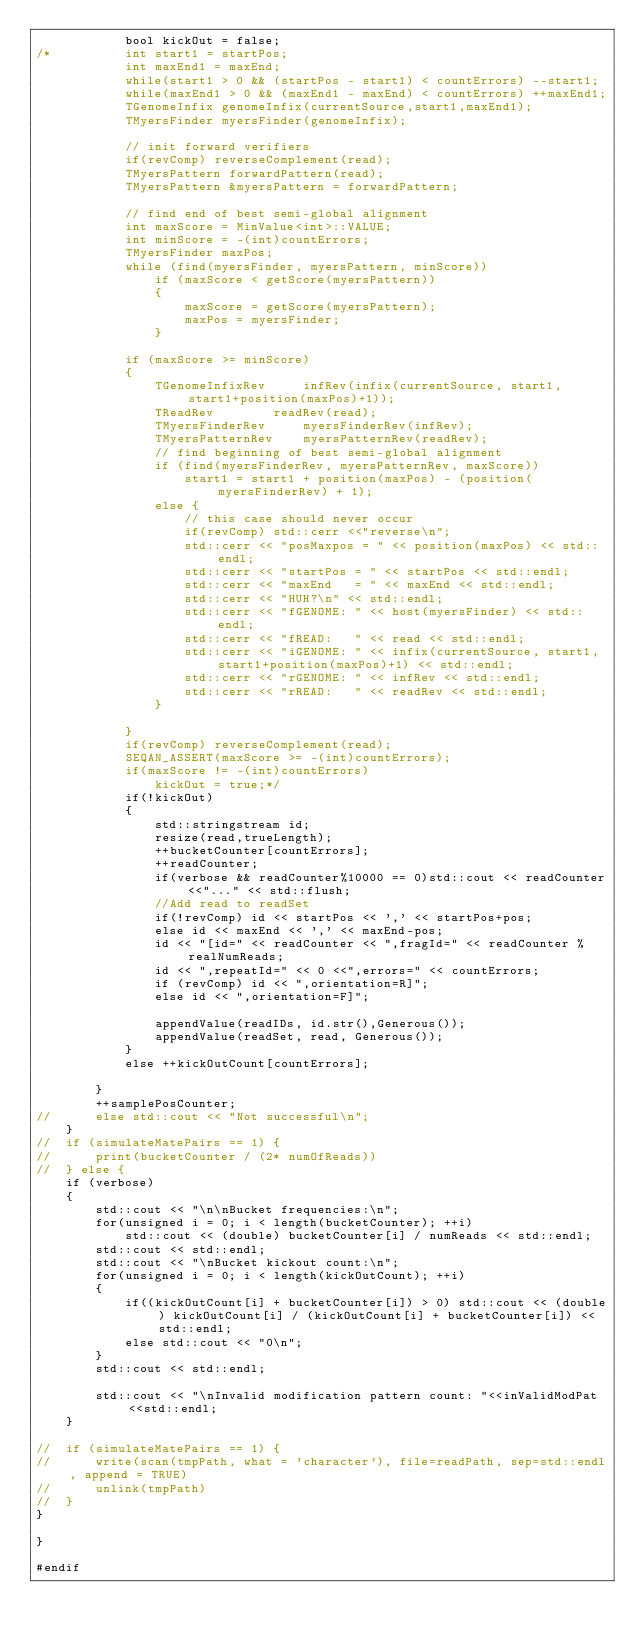<code> <loc_0><loc_0><loc_500><loc_500><_C_>			bool kickOut = false;
/*			int start1 = startPos;
			int maxEnd1 = maxEnd;
			while(start1 > 0 && (startPos - start1) < countErrors) --start1;
			while(maxEnd1 > 0 && (maxEnd1 - maxEnd) < countErrors) ++maxEnd1;
			TGenomeInfix genomeInfix(currentSource,start1,maxEnd1);
			TMyersFinder myersFinder(genomeInfix);

			// init forward verifiers
			if(revComp) reverseComplement(read);
			TMyersPattern forwardPattern(read);
			TMyersPattern &myersPattern = forwardPattern;
			
			// find end of best semi-global alignment
			int maxScore = MinValue<int>::VALUE;
			int minScore = -(int)countErrors;
			TMyersFinder maxPos;
			while (find(myersFinder, myersPattern, minScore))
				if (maxScore < getScore(myersPattern)) 
				{
					maxScore = getScore(myersPattern);
					maxPos = myersFinder;
				}
			
			if (maxScore >= minScore) 
			{
				TGenomeInfixRev		infRev(infix(currentSource, start1, start1+position(maxPos)+1));
				TReadRev		readRev(read);
				TMyersFinderRev		myersFinderRev(infRev);
				TMyersPatternRev	myersPatternRev(readRev);
				// find beginning of best semi-global alignment
				if (find(myersFinderRev, myersPatternRev, maxScore))
					start1 = start1 + position(maxPos) - (position(myersFinderRev) + 1);
				else {
					// this case should never occur
					if(revComp) std::cerr <<"reverse\n";
					std::cerr << "posMaxpos = " << position(maxPos) << std::endl;
					std::cerr << "startPos = " << startPos << std::endl;
					std::cerr << "maxEnd   = " << maxEnd << std::endl;
					std::cerr << "HUH?\n" << std::endl;
					std::cerr << "fGENOME: " << host(myersFinder) << std::endl;
					std::cerr << "fREAD:   " << read << std::endl;
					std::cerr << "iGENOME: " << infix(currentSource, start1,start1+position(maxPos)+1) << std::endl;
					std::cerr << "rGENOME: " << infRev << std::endl;
					std::cerr << "rREAD:   " << readRev << std::endl;
				}
			
			} 
			if(revComp) reverseComplement(read);
			SEQAN_ASSERT(maxScore >= -(int)countErrors);
			if(maxScore != -(int)countErrors)
				kickOut = true;*/
			if(!kickOut)
			{
				std::stringstream id;
				resize(read,trueLength);
				++bucketCounter[countErrors];
				++readCounter;
				if(verbose && readCounter%10000 == 0)std::cout << readCounter<<"..." << std::flush;
				//Add read to readSet
				if(!revComp) id << startPos << ',' << startPos+pos;
				else id << maxEnd << ',' << maxEnd-pos;
				id << "[id=" << readCounter << ",fragId=" << readCounter % realNumReads;
				id << ",repeatId=" << 0 <<",errors=" << countErrors;
				if (revComp) id << ",orientation=R]";
				else id << ",orientation=F]";

				appendValue(readIDs, id.str(),Generous());
				appendValue(readSet, read, Generous());
			}
			else ++kickOutCount[countErrors];

		}
		++samplePosCounter;
//		else std::cout << "Not successful\n";
	}
//	if (simulateMatePairs == 1) {
//		print(bucketCounter / (2* numOfReads))
//	} else {
	if (verbose)
	{
		std::cout << "\n\nBucket frequencies:\n";
		for(unsigned i = 0; i < length(bucketCounter); ++i)
			std::cout << (double) bucketCounter[i] / numReads << std::endl;
		std::cout << std::endl;
		std::cout << "\nBucket kickout count:\n";
		for(unsigned i = 0; i < length(kickOutCount); ++i)
		{
			if((kickOutCount[i] + bucketCounter[i]) > 0) std::cout << (double) kickOutCount[i] / (kickOutCount[i] + bucketCounter[i]) << std::endl;
			else std::cout << "0\n";
		}
		std::cout << std::endl;
		
		std::cout << "\nInvalid modification pattern count: "<<inValidModPat<<std::endl;
	}

//	if (simulateMatePairs == 1) {
//		write(scan(tmpPath, what = 'character'), file=readPath, sep=std::endl, append = TRUE)
//		unlink(tmpPath)
//	}
}

}

#endif
</code> 